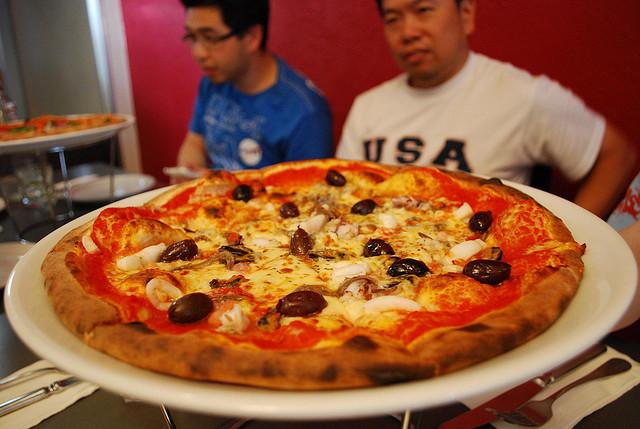What color is the plate?
Answer briefly. White. What shape is the white dish?
Quick response, please. Circle. Is the pizza delicious?
Concise answer only. Yes. 